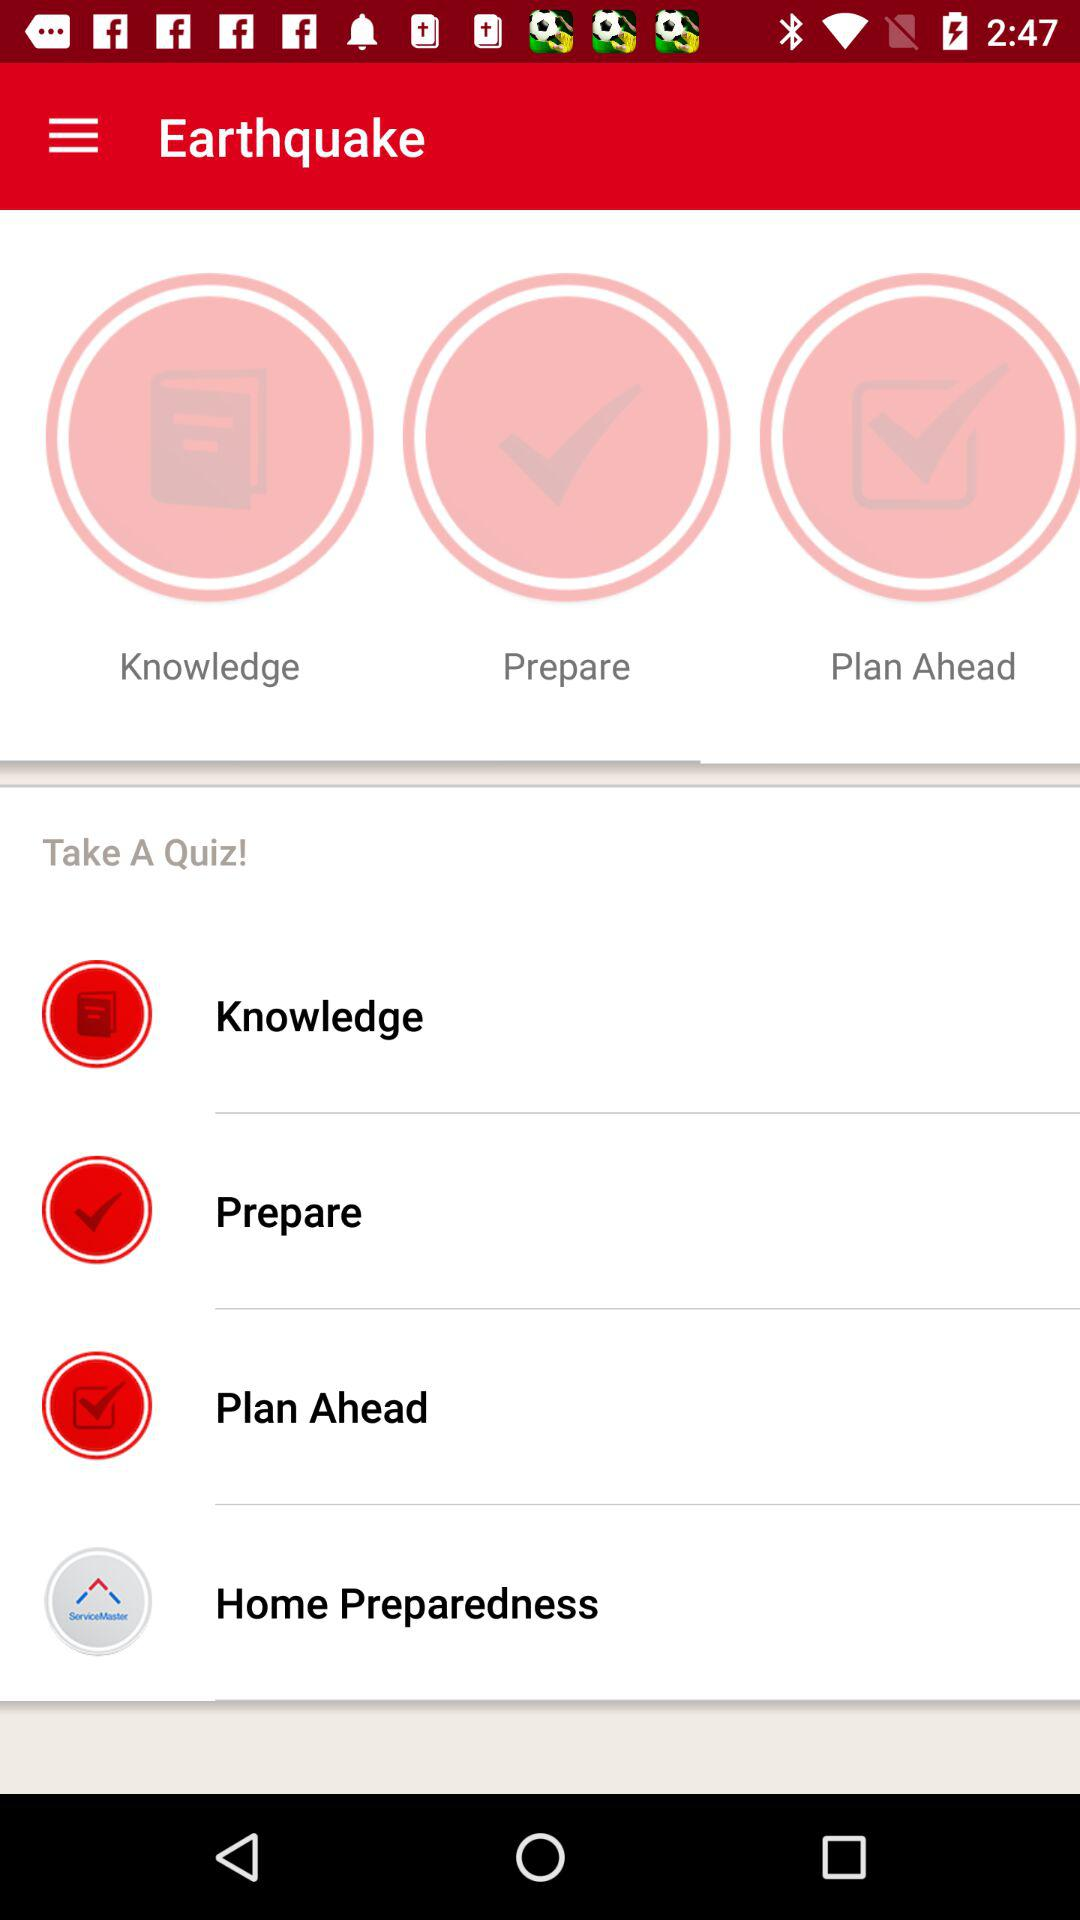What is the application name? The application name is "Earthquake". 